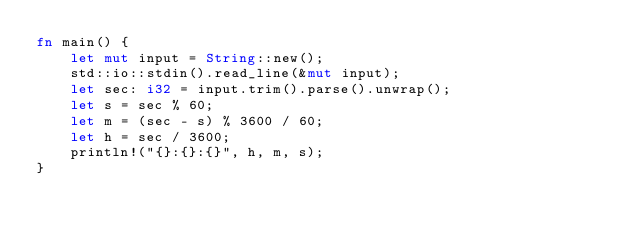<code> <loc_0><loc_0><loc_500><loc_500><_Rust_>fn main() {
    let mut input = String::new();
    std::io::stdin().read_line(&mut input);
    let sec: i32 = input.trim().parse().unwrap();
    let s = sec % 60;
    let m = (sec - s) % 3600 / 60;
    let h = sec / 3600;
    println!("{}:{}:{}", h, m, s);
}

</code> 